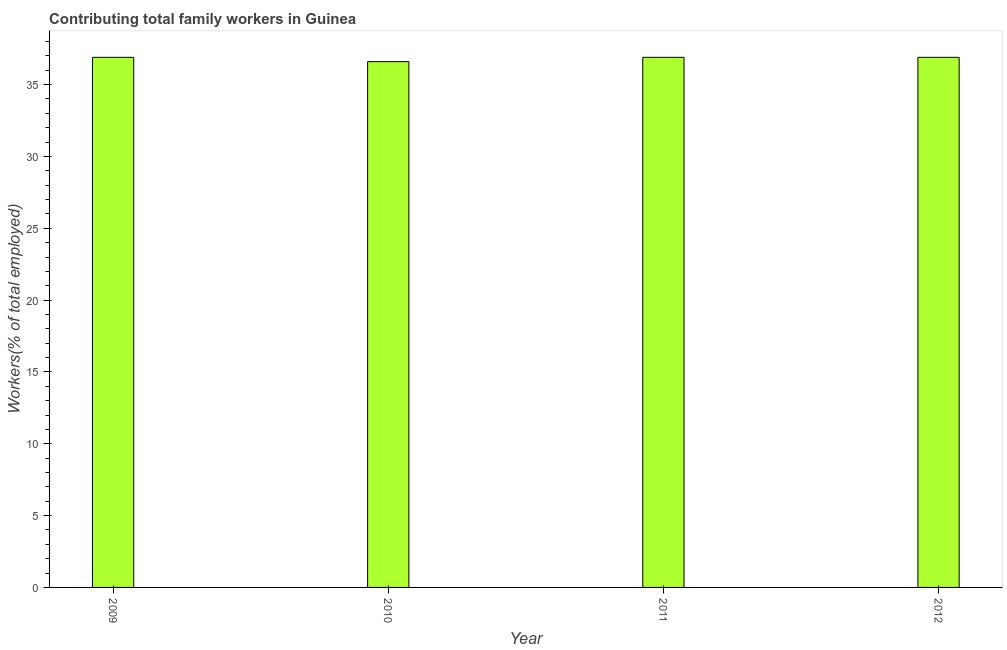Does the graph contain any zero values?
Keep it short and to the point. No. Does the graph contain grids?
Provide a succinct answer. No. What is the title of the graph?
Give a very brief answer. Contributing total family workers in Guinea. What is the label or title of the X-axis?
Make the answer very short. Year. What is the label or title of the Y-axis?
Your answer should be compact. Workers(% of total employed). What is the contributing family workers in 2009?
Ensure brevity in your answer.  36.9. Across all years, what is the maximum contributing family workers?
Your answer should be compact. 36.9. Across all years, what is the minimum contributing family workers?
Your answer should be compact. 36.6. In which year was the contributing family workers maximum?
Your response must be concise. 2009. What is the sum of the contributing family workers?
Your answer should be compact. 147.3. What is the difference between the contributing family workers in 2010 and 2012?
Give a very brief answer. -0.3. What is the average contributing family workers per year?
Offer a terse response. 36.83. What is the median contributing family workers?
Provide a succinct answer. 36.9. In how many years, is the contributing family workers greater than 17 %?
Your response must be concise. 4. What is the ratio of the contributing family workers in 2010 to that in 2012?
Make the answer very short. 0.99. Is the difference between the contributing family workers in 2009 and 2011 greater than the difference between any two years?
Make the answer very short. No. What is the difference between the highest and the second highest contributing family workers?
Your answer should be very brief. 0. Are all the bars in the graph horizontal?
Your answer should be very brief. No. What is the difference between two consecutive major ticks on the Y-axis?
Make the answer very short. 5. Are the values on the major ticks of Y-axis written in scientific E-notation?
Offer a very short reply. No. What is the Workers(% of total employed) of 2009?
Make the answer very short. 36.9. What is the Workers(% of total employed) of 2010?
Provide a short and direct response. 36.6. What is the Workers(% of total employed) of 2011?
Provide a short and direct response. 36.9. What is the Workers(% of total employed) in 2012?
Give a very brief answer. 36.9. What is the difference between the Workers(% of total employed) in 2009 and 2011?
Provide a short and direct response. 0. What is the ratio of the Workers(% of total employed) in 2009 to that in 2011?
Ensure brevity in your answer.  1. 